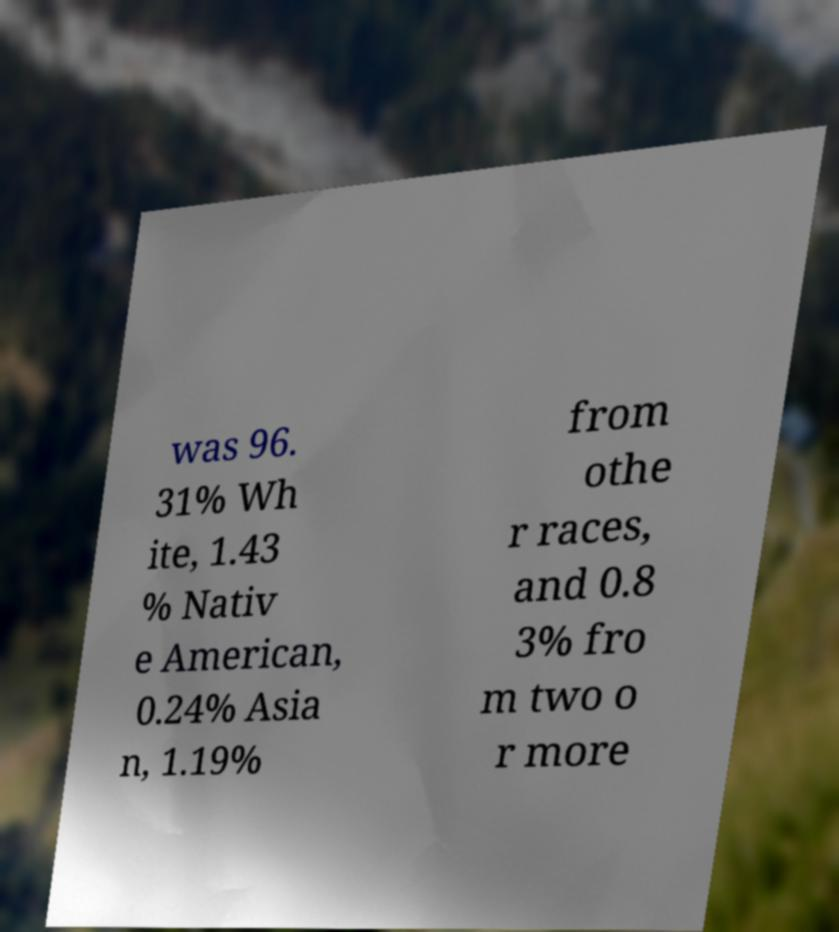Can you accurately transcribe the text from the provided image for me? was 96. 31% Wh ite, 1.43 % Nativ e American, 0.24% Asia n, 1.19% from othe r races, and 0.8 3% fro m two o r more 